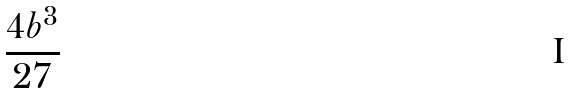<formula> <loc_0><loc_0><loc_500><loc_500>\frac { 4 b ^ { 3 } } { 2 7 }</formula> 